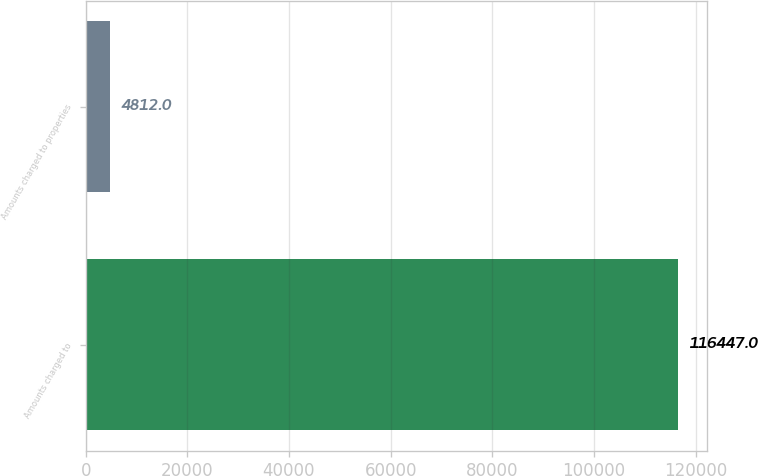Convert chart to OTSL. <chart><loc_0><loc_0><loc_500><loc_500><bar_chart><fcel>Amounts charged to<fcel>Amounts charged to properties<nl><fcel>116447<fcel>4812<nl></chart> 